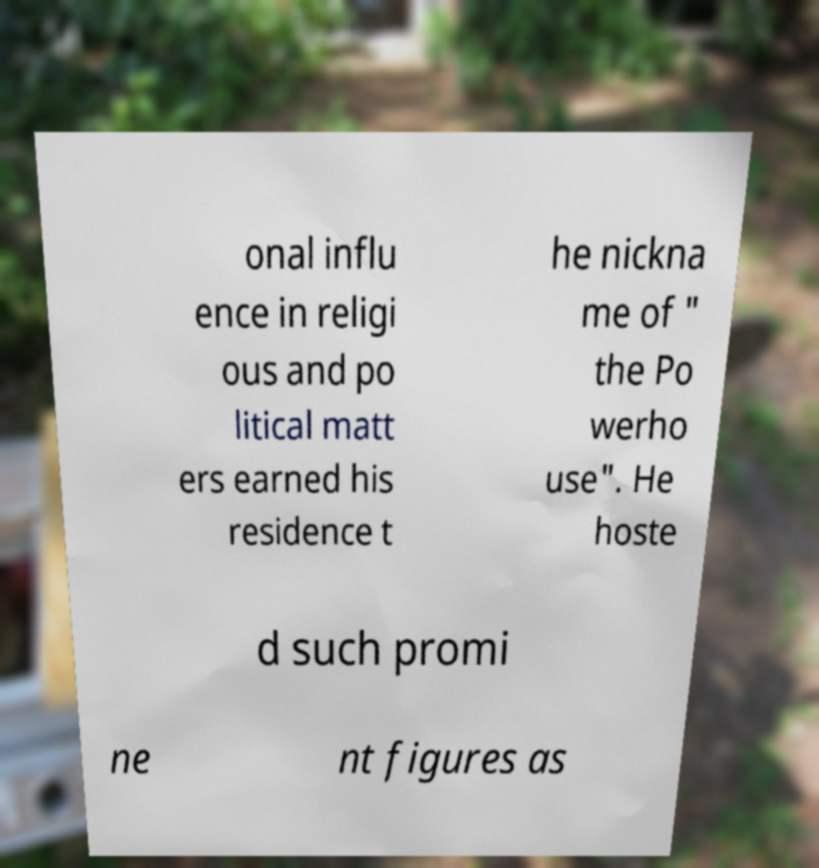Could you assist in decoding the text presented in this image and type it out clearly? onal influ ence in religi ous and po litical matt ers earned his residence t he nickna me of " the Po werho use". He hoste d such promi ne nt figures as 